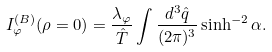<formula> <loc_0><loc_0><loc_500><loc_500>I ^ { ( B ) } _ { \varphi } ( \rho = 0 ) = \frac { \lambda _ { \varphi } } { \hat { T } } \int \frac { d ^ { 3 } \hat { q } } { ( 2 \pi ) ^ { 3 } } \sinh ^ { - 2 } \alpha .</formula> 